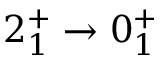Convert formula to latex. <formula><loc_0><loc_0><loc_500><loc_500>2 _ { 1 } ^ { + } \rightarrow 0 _ { 1 } ^ { + }</formula> 